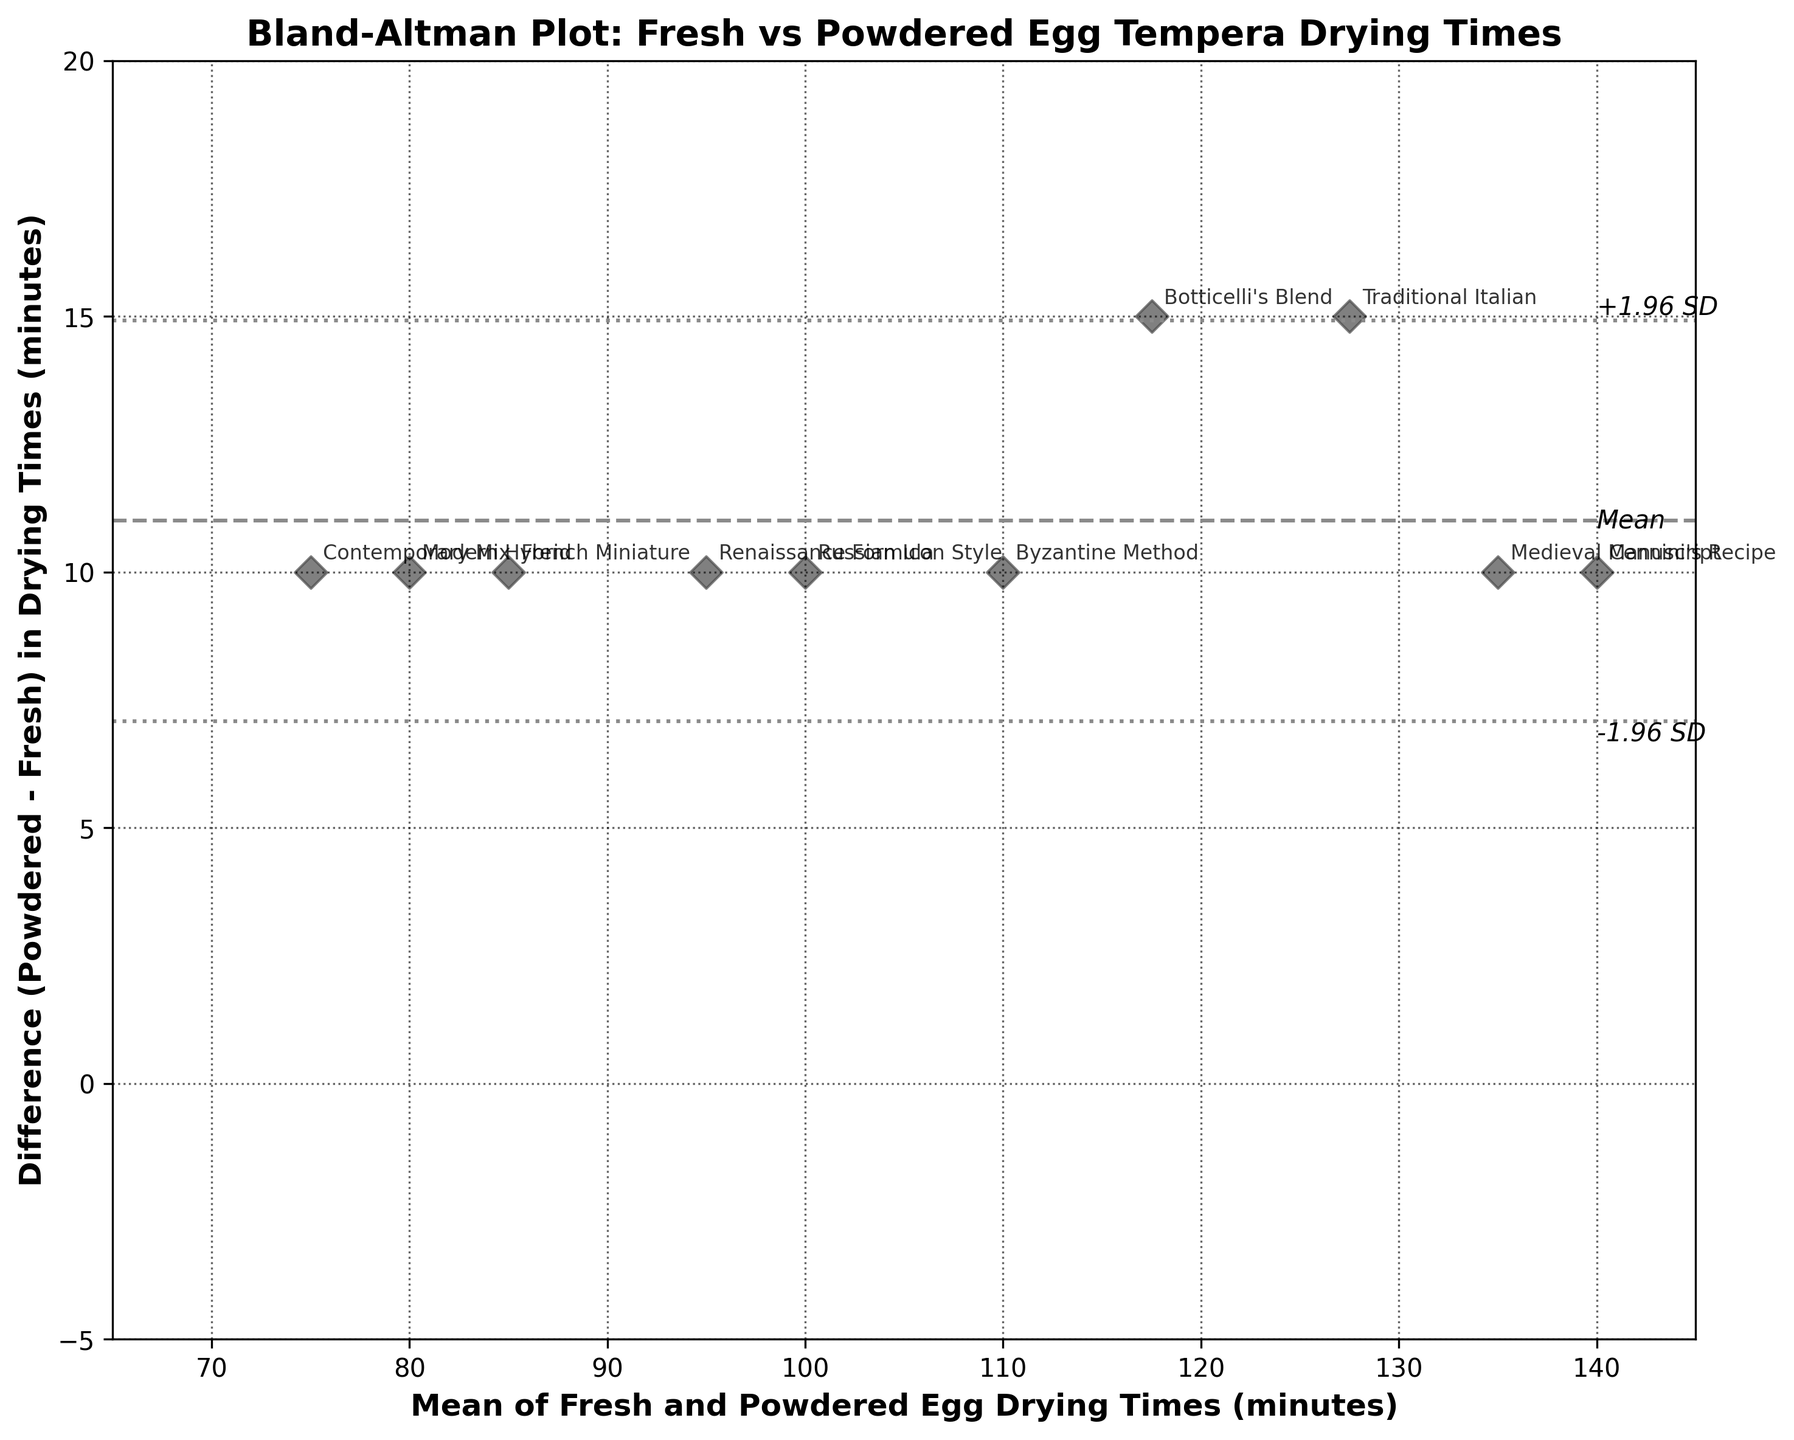What's the title of the figure? The title of the figure is usually found at the top and provides an overview of what the plot represents. In this case, the title states what kind of plot it is and what it compares.
Answer: Bland-Altman Plot: Fresh vs Powdered Egg Tempera Drying Times What do the x-axis and y-axis represent? The labels on the axes describe what each axis represents. Here, the x-axis indicates the average drying time between fresh and powdered eggs, while the y-axis shows the difference in drying times between powdered and fresh eggs.
Answer: x-axis: Mean of Fresh and Powdered Egg Drying Times (minutes); y-axis: Difference (Powdered - Fresh) in Drying Times (minutes) What is the mean difference in drying times between the fresh and powdered egg recipes? The mean difference is indicated by the dashed horizontal line in the plot and is also labeled as 'Mean'.
Answer: 10 minutes Which recipe has the highest difference in drying time? By comparing the vertical displacement of points on the plot, the point at the highest y-value shows the largest difference between fresh and powdered egg drying times.
Answer: Botticelli's Blend What are the upper and lower limits of agreement in the plot? The upper and lower limits of agreement are typically displayed as dotted lines above and below the mean difference line, indicating ±1.96 times the standard deviation from the mean.
Answer: Upper: 15.28 minutes, Lower: 4.72 minutes How many recipes have a shorter drying time difference than the mean? By observing the points below the mean line on the y-axis, we can count the number of recipes that have a drying time difference below the mean.
Answer: 4 recipes Which recipes lie within the upper and lower limits of agreement? Points that fall between the dotted lines of ±1.96 SD from the mean indicate the recipes within the limits of agreement.
Answer: Traditional Italian, Byzantine Method, Renaissance Formula, Modern Hybrid, Russian Icon Style, French Miniature, Medieval Manuscript, Contemporary Mix What is the average drying time of the 'Modern Hybrid' recipe? The x-axis represents the mean drying time. Locate the 'Modern Hybrid' label on the scatter plot and check its x-axis value.
Answer: 80 minutes Which recipe has the closest drying times between fresh and powdered eggs? The recipe with the smallest difference on the y-axis, where the difference value is closest to zero, indicates nearly equal drying times.
Answer: Renaissance Formula Is there a general trend in the drying times between fresh and powdered eggs? By observing the scatter plot, note if the differences are consistently positive or negative, indicating whether powdered eggs generally dry faster or slower than fresh eggs.
Answer: Powdered eggs generally dry slower 